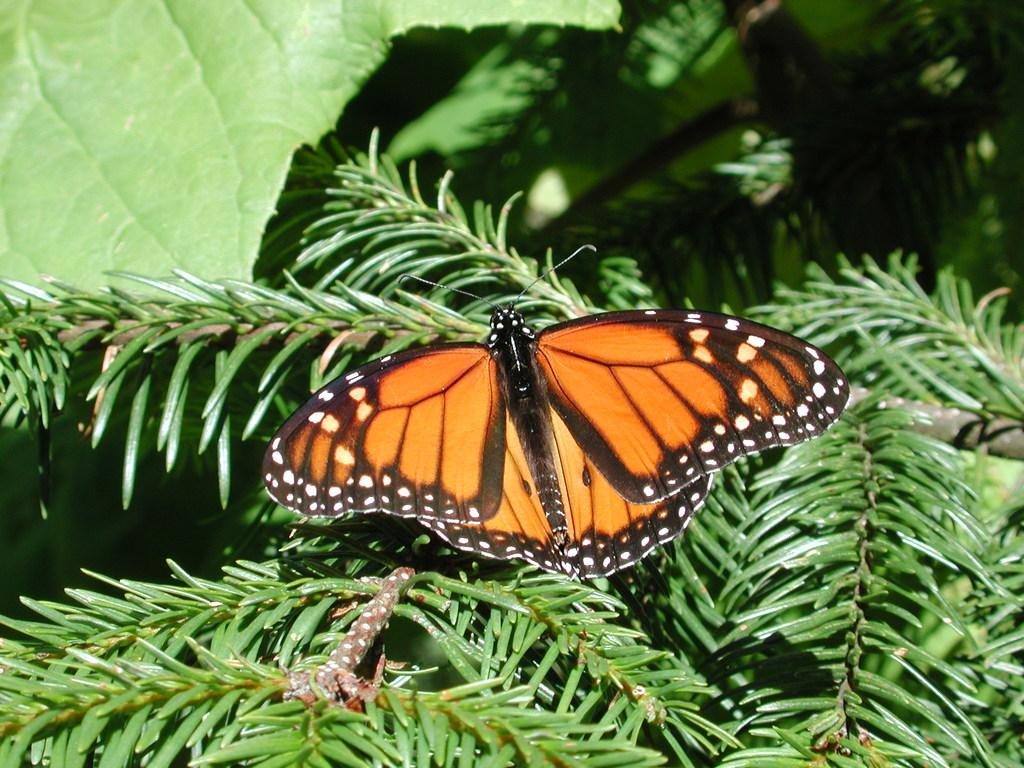What is the main subject of the image? There is a butterfly in the image. Where is the butterfly located? The butterfly is on a plant. What type of truck can be seen in the image? There is no truck present in the image; it features a butterfly on a plant. Is the butterfly in space in the image? No, the butterfly is on a plant, not in space. 